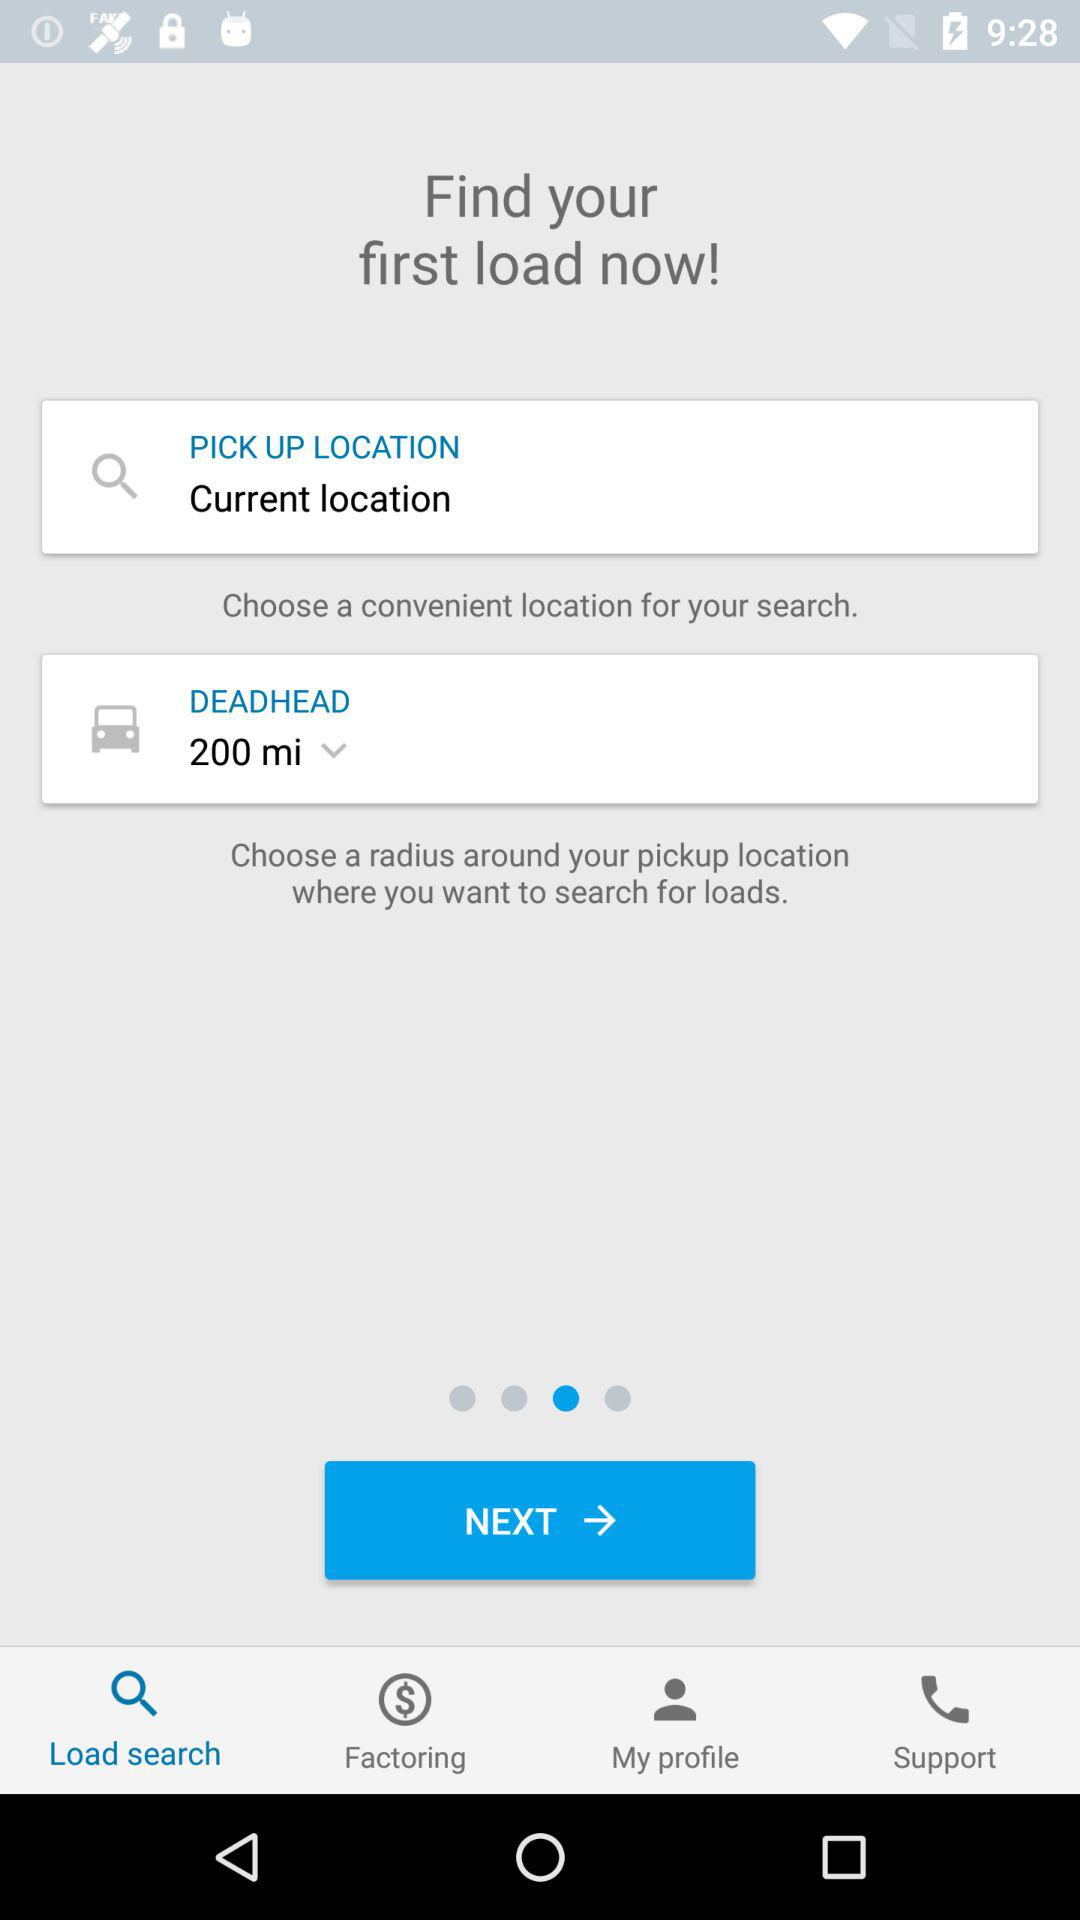What is the selected option in "DEADHEAD"? The selected option is "200 mi". 